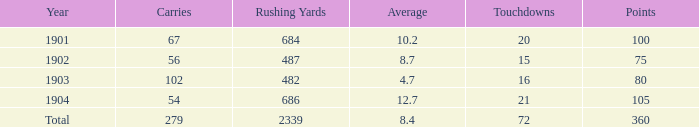7, and under 487 rushing yards? None. 